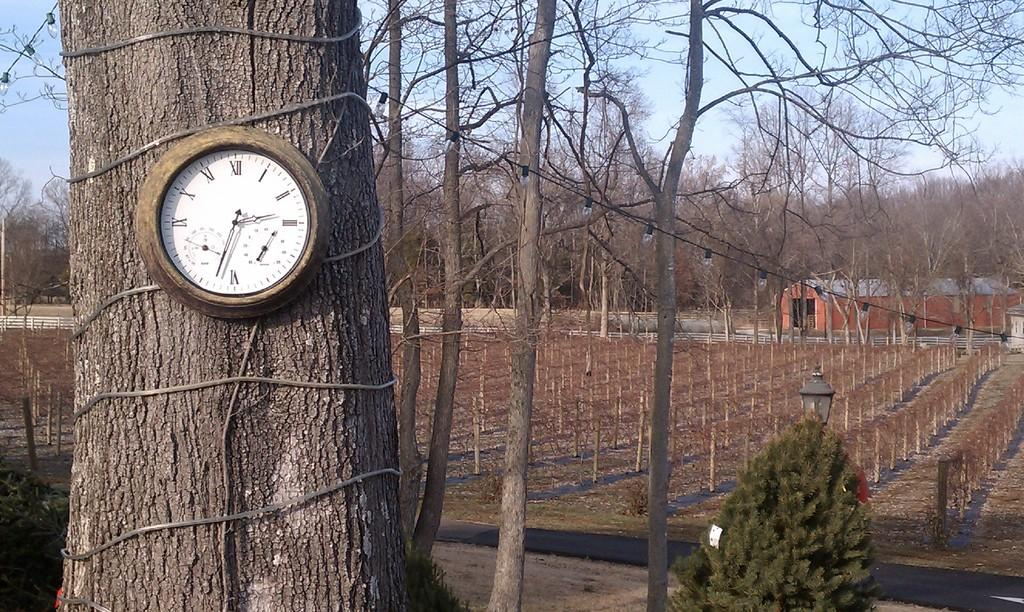<image>
Create a compact narrative representing the image presented. A clock is outdoors on a tree and says that the time is 2:33. 